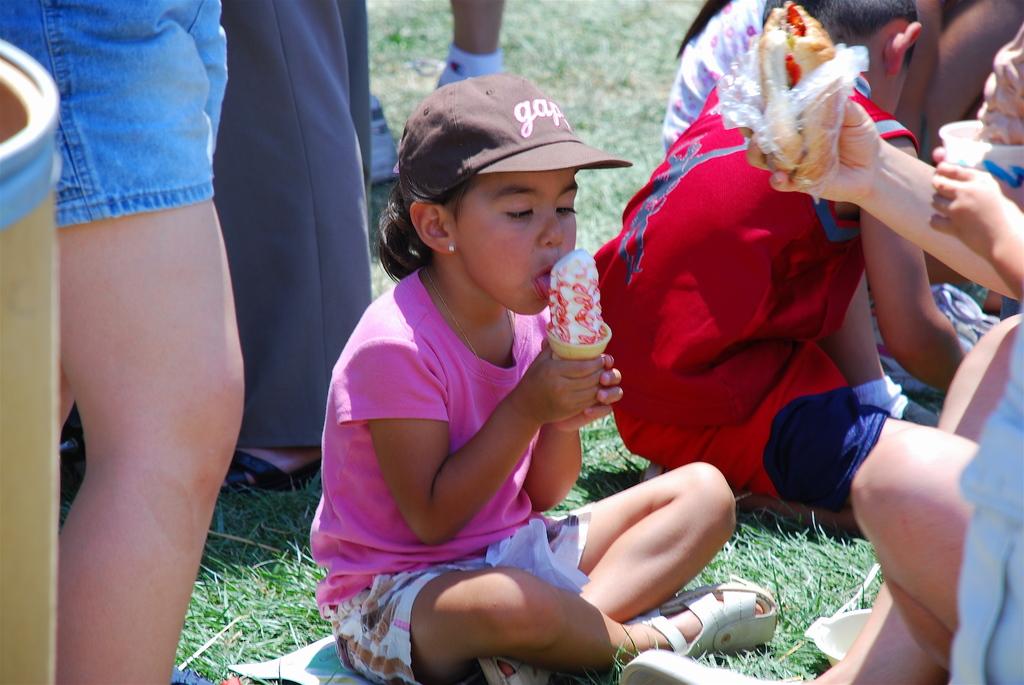What is the brand of the cap?
Your answer should be very brief. Gap. 